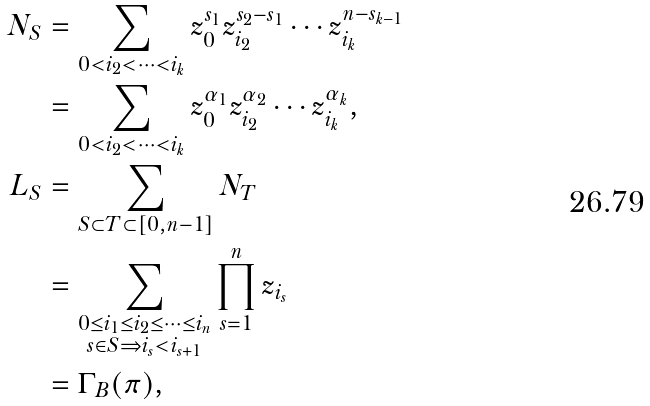Convert formula to latex. <formula><loc_0><loc_0><loc_500><loc_500>N _ { S } & = \sum _ { 0 < i _ { 2 } < \cdots < i _ { k } } z _ { 0 } ^ { s _ { 1 } } z _ { i _ { 2 } } ^ { s _ { 2 } - s _ { 1 } } \cdots z _ { i _ { k } } ^ { n - s _ { k - 1 } } \\ & = \sum _ { 0 < i _ { 2 } < \cdots < i _ { k } } z _ { 0 } ^ { \alpha _ { 1 } } z _ { i _ { 2 } } ^ { \alpha _ { 2 } } \cdots z _ { i _ { k } } ^ { \alpha _ { k } } , \\ L _ { S } & = \sum _ { S \subset T \subset [ 0 , n - 1 ] } N _ { T } \\ & = \sum _ { \substack { 0 \leq i _ { 1 } \leq i _ { 2 } \leq \cdots \leq i _ { n } \\ s \in S \Rightarrow i _ { s } < i _ { s + 1 } } } \prod _ { s = 1 } ^ { n } z _ { i _ { s } } \\ & = \Gamma _ { B } ( \pi ) ,</formula> 